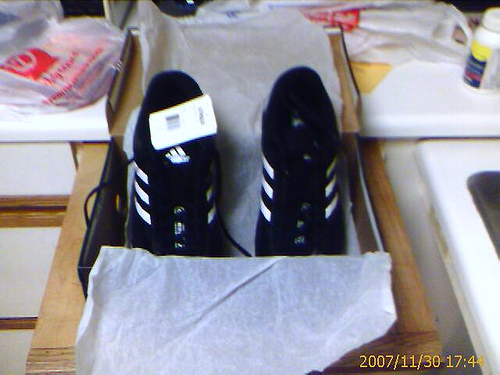<image>
Is the shoe in front of the bottle? Yes. The shoe is positioned in front of the bottle, appearing closer to the camera viewpoint. Where is the shoe in relation to the shoe? Is it in front of the shoe? No. The shoe is not in front of the shoe. The spatial positioning shows a different relationship between these objects. 